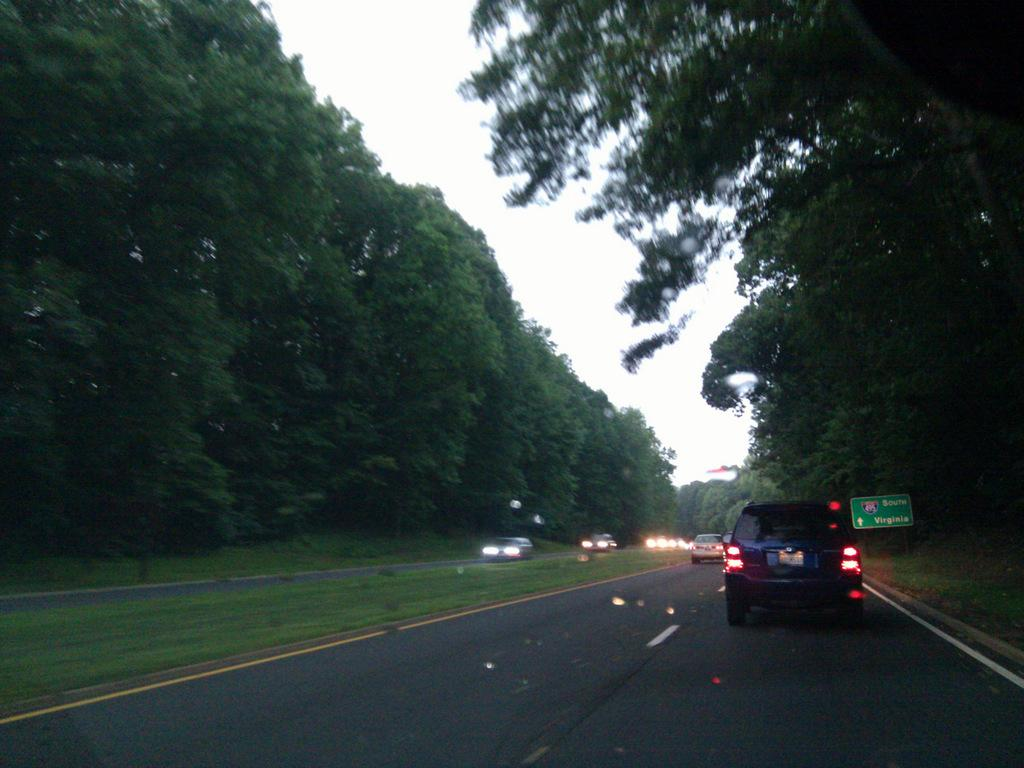What is happening in the foreground of the image? There are vehicles moving on the road in the foreground of the image. What can be seen on either side of the road? Trees are present on either side of the road. What is visible at the top of the image? The sky is visible at the top of the image. Where is the loaf of bread located in the image? There is no loaf of bread present in the image. Can you tell me how many copies of the same vehicle are visible in the image? The image does not show multiple copies of the same vehicle; it only shows vehicles moving on the road. 